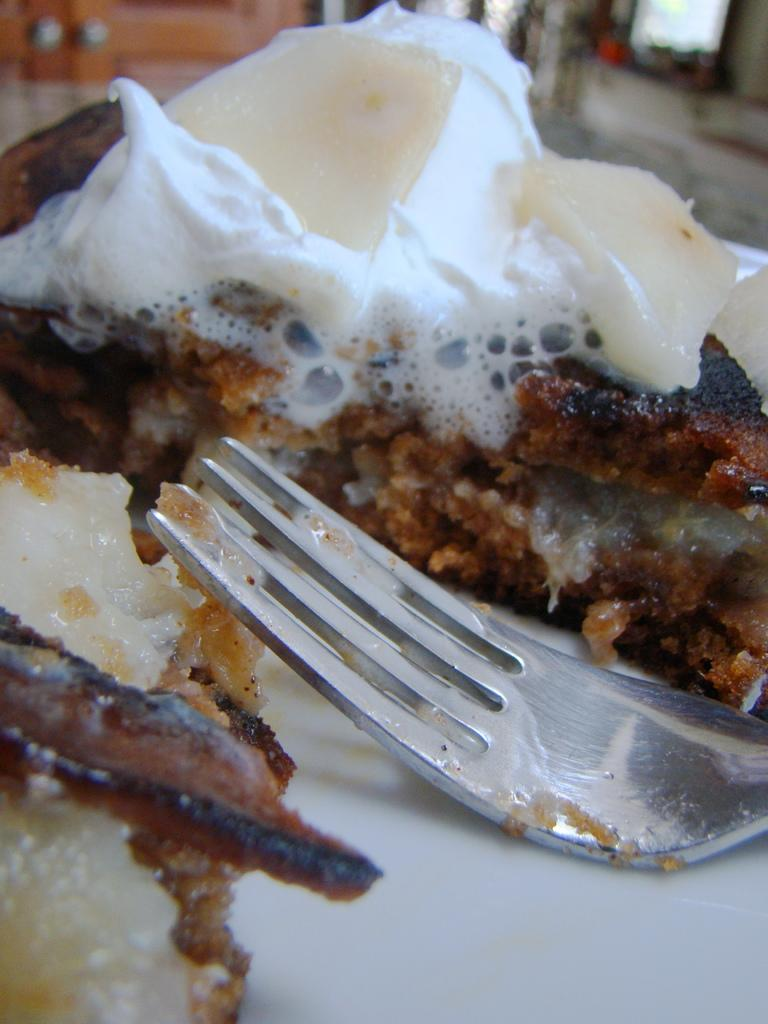What is the main subject of the image? There is a food item in the image. What utensil is present in the image? There is a fork in the image. How is the food item arranged in the image? The food item is on a plate. Can you describe the background of the image? The background of the image is blurred. What type of coat is hanging on the ship in the image? There is no coat or ship present in the image; it features a food item, a fork, and a blurred background. 